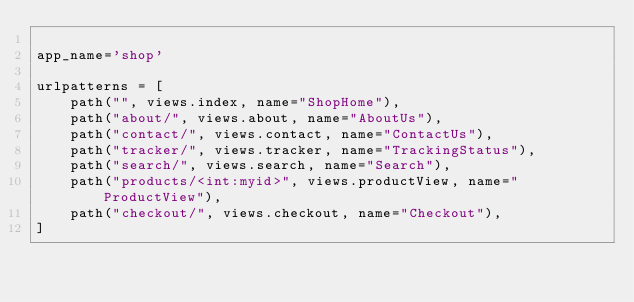<code> <loc_0><loc_0><loc_500><loc_500><_Python_>
app_name='shop'

urlpatterns = [
    path("", views.index, name="ShopHome"),
    path("about/", views.about, name="AboutUs"),
    path("contact/", views.contact, name="ContactUs"),
    path("tracker/", views.tracker, name="TrackingStatus"),
    path("search/", views.search, name="Search"),
    path("products/<int:myid>", views.productView, name="ProductView"),
    path("checkout/", views.checkout, name="Checkout"),
]</code> 